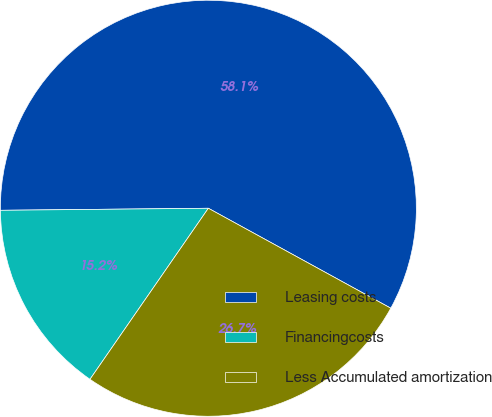Convert chart. <chart><loc_0><loc_0><loc_500><loc_500><pie_chart><fcel>Leasing costs<fcel>Financingcosts<fcel>Less Accumulated amortization<nl><fcel>58.14%<fcel>15.21%<fcel>26.66%<nl></chart> 